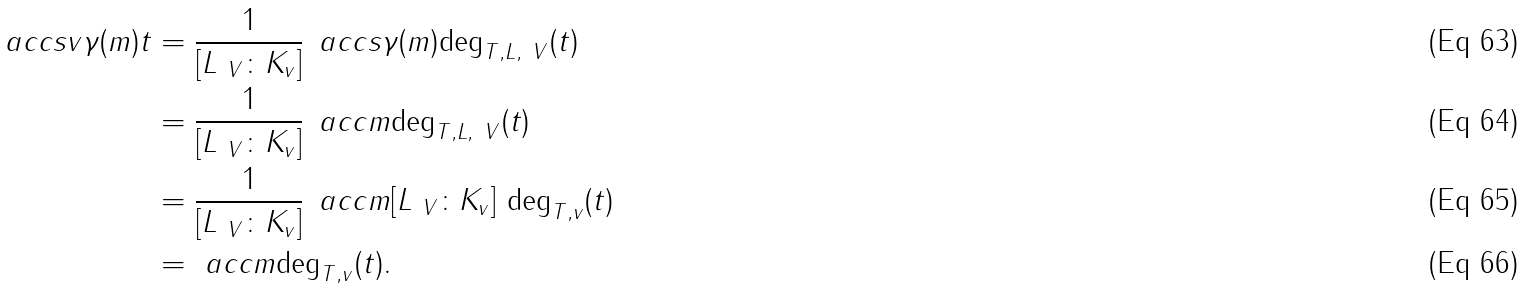<formula> <loc_0><loc_0><loc_500><loc_500>\ a c c s v { \gamma ( m ) } { t } & = \frac { 1 } { [ L _ { \ V } \colon K _ { v } ] } \, \ a c c s { \gamma ( m ) } { \deg _ { T , L , \ V } ( t ) } \\ & = \frac { 1 } { [ L _ { \ V } \colon K _ { v } ] } \, \ a c c { m } { \deg _ { T , L , \ V } ( t ) } \\ & = \frac { 1 } { [ L _ { \ V } \colon K _ { v } ] } \, \ a c c { m } { [ L _ { \ V } \colon K _ { v } ] \, \deg _ { T , v } ( t ) } \\ & = \ a c c { m } { \deg _ { T , v } ( t ) } .</formula> 